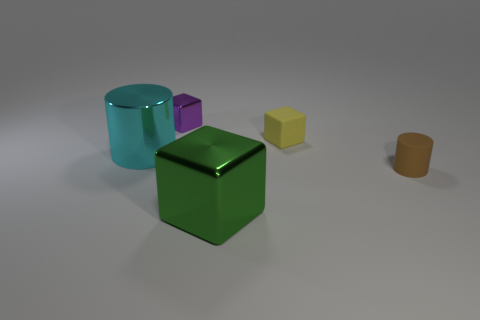Add 1 large cyan objects. How many large cyan objects are left? 2 Add 1 large blue matte cubes. How many large blue matte cubes exist? 1 Add 1 small brown metal blocks. How many objects exist? 6 Subtract all brown cylinders. How many cylinders are left? 1 Subtract all yellow matte blocks. How many blocks are left? 2 Subtract 0 gray cylinders. How many objects are left? 5 Subtract all blocks. How many objects are left? 2 Subtract all green cubes. Subtract all cyan spheres. How many cubes are left? 2 Subtract all cyan spheres. How many green blocks are left? 1 Subtract all large green blocks. Subtract all large cyan things. How many objects are left? 3 